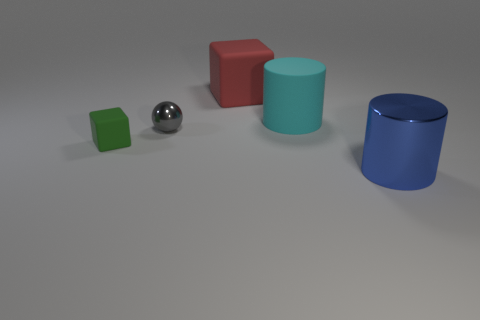Add 5 large blue blocks. How many objects exist? 10 Subtract all cubes. How many objects are left? 3 Subtract all tiny shiny things. Subtract all cyan matte things. How many objects are left? 3 Add 3 small gray metallic things. How many small gray metallic things are left? 4 Add 4 small green shiny balls. How many small green shiny balls exist? 4 Subtract 1 red blocks. How many objects are left? 4 